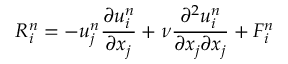<formula> <loc_0><loc_0><loc_500><loc_500>R _ { i } ^ { n } = - u _ { j } ^ { n } \frac { \partial u _ { i } ^ { n } } { \partial x _ { j } } + \nu \frac { \partial ^ { 2 } u _ { i } ^ { n } } { \partial x _ { j } \partial x _ { j } } + F _ { i } ^ { n }</formula> 